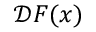<formula> <loc_0><loc_0><loc_500><loc_500>\mathcal { D } F ( x )</formula> 